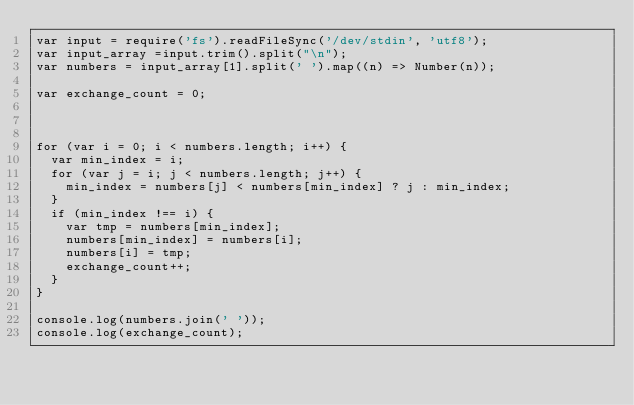Convert code to text. <code><loc_0><loc_0><loc_500><loc_500><_JavaScript_>var input = require('fs').readFileSync('/dev/stdin', 'utf8');
var input_array =input.trim().split("\n");
var numbers = input_array[1].split(' ').map((n) => Number(n));

var exchange_count = 0;



for (var i = 0; i < numbers.length; i++) {
  var min_index = i;
  for (var j = i; j < numbers.length; j++) {
    min_index = numbers[j] < numbers[min_index] ? j : min_index; 
  }
  if (min_index !== i) {
    var tmp = numbers[min_index];
    numbers[min_index] = numbers[i];
    numbers[i] = tmp;
    exchange_count++;
  }
}

console.log(numbers.join(' '));
console.log(exchange_count);
</code> 